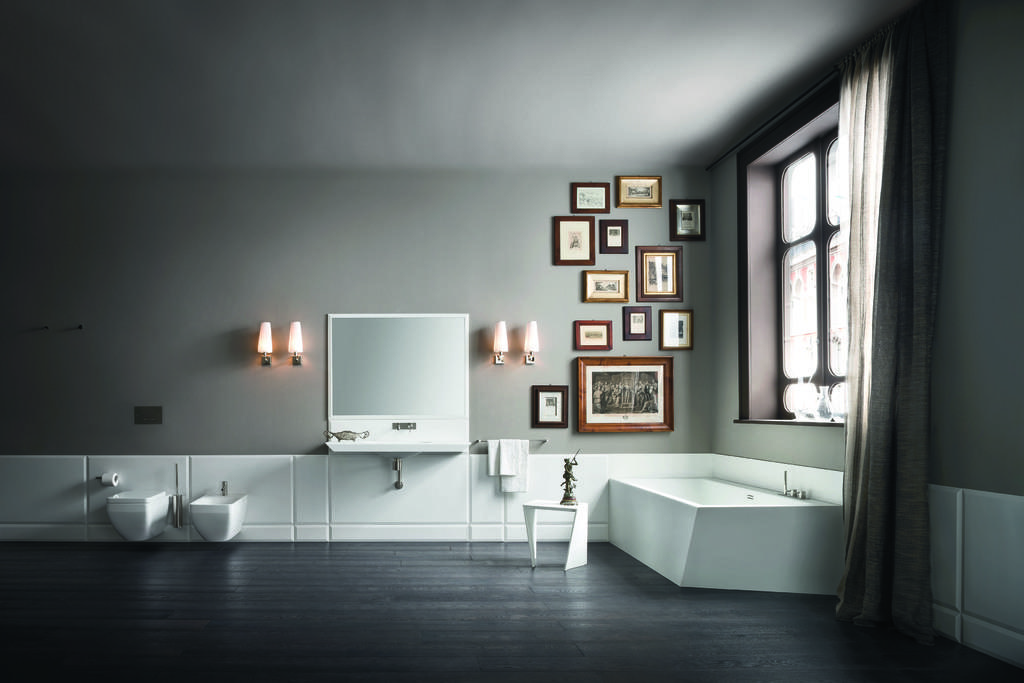What can be seen hanging on the wall in the image? There are frames on the wall in the image. What type of lighting is present in the image? There are lamps in the image. What items might be used for drying or cleaning in the image? Towels are present in the image. What is on the stool on the floor in the image? There is a statue on the stool on the floor. What is located near the window in the image? There is a tissue paper roll in the image. What type of window treatment is present in the image? There is a curtain associated with the window in the image. Can you describe any unspecified objects in the image? Unfortunately, the provided facts do not specify the nature of the unspecified objects in the image. What type of dress is the statue wearing in the image? The statue in the image is not a person, so it is not wearing a dress. How does the statue breathe in the image? The statue is not a living being, so it does not breathe. 